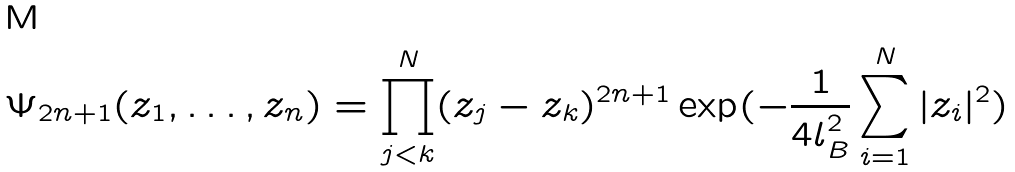Convert formula to latex. <formula><loc_0><loc_0><loc_500><loc_500>\Psi _ { 2 n + 1 } ( z _ { 1 } , \dots , z _ { n } ) = \prod _ { j < k } ^ { N } ( z _ { j } - z _ { k } ) ^ { 2 n + 1 } \exp ( - \frac { 1 } { 4 l _ { B } ^ { 2 } } \sum _ { i = 1 } ^ { N } | z _ { i } | ^ { 2 } )</formula> 